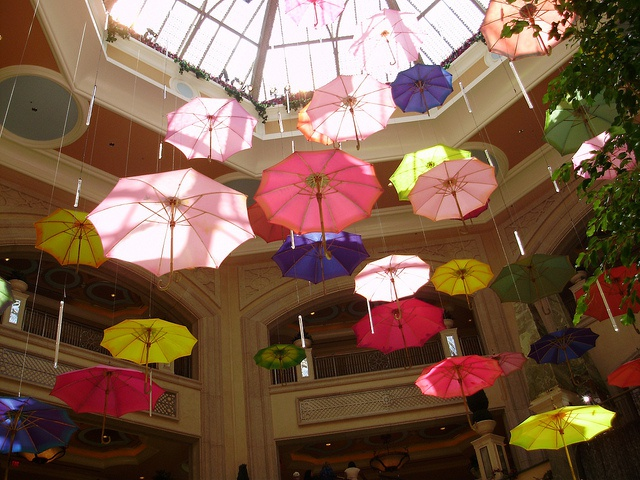Describe the objects in this image and their specific colors. I can see umbrella in maroon, black, white, and olive tones, umbrella in maroon, lavender, lightpink, brown, and pink tones, umbrella in maroon, salmon, and brown tones, umbrella in maroon, lavender, lightpink, pink, and salmon tones, and umbrella in maroon, white, lightpink, salmon, and pink tones in this image. 